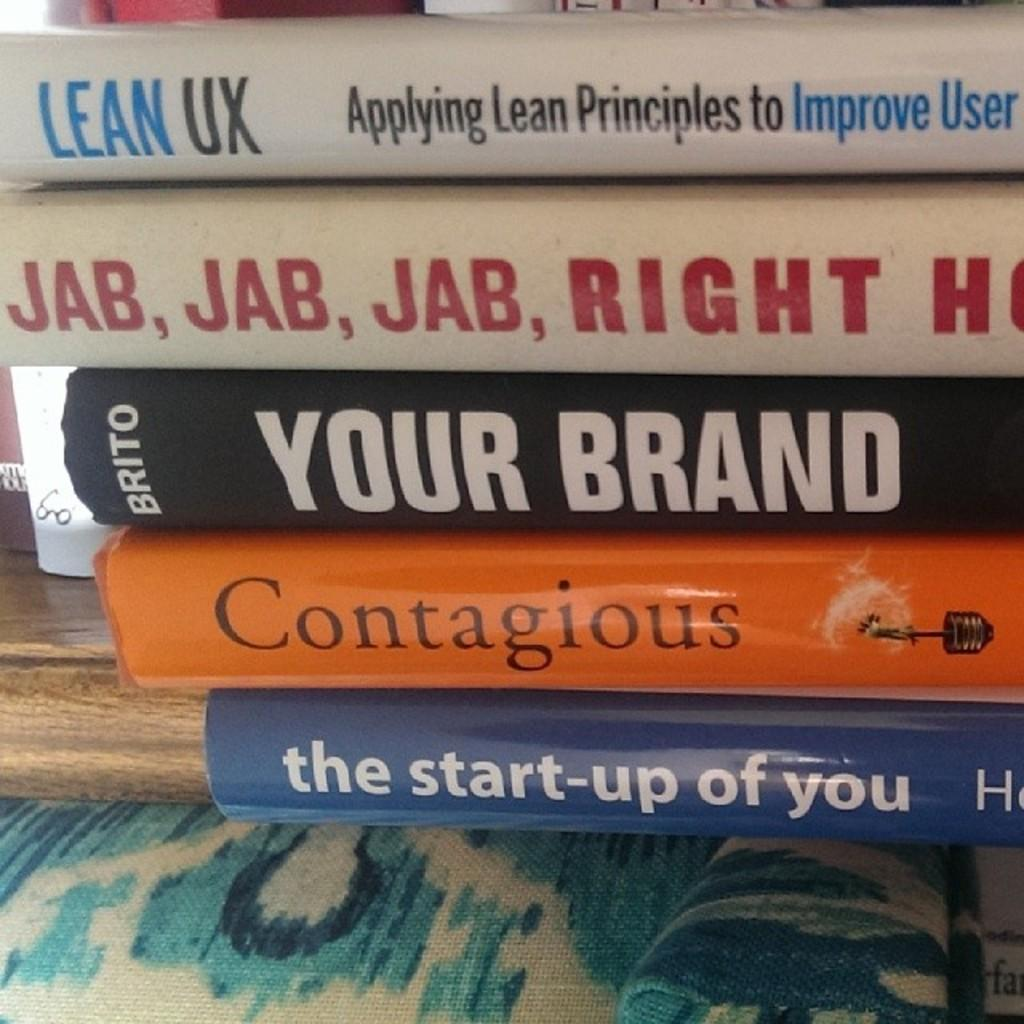Provide a one-sentence caption for the provided image. Books on self improvement are stacked on top of each other. 